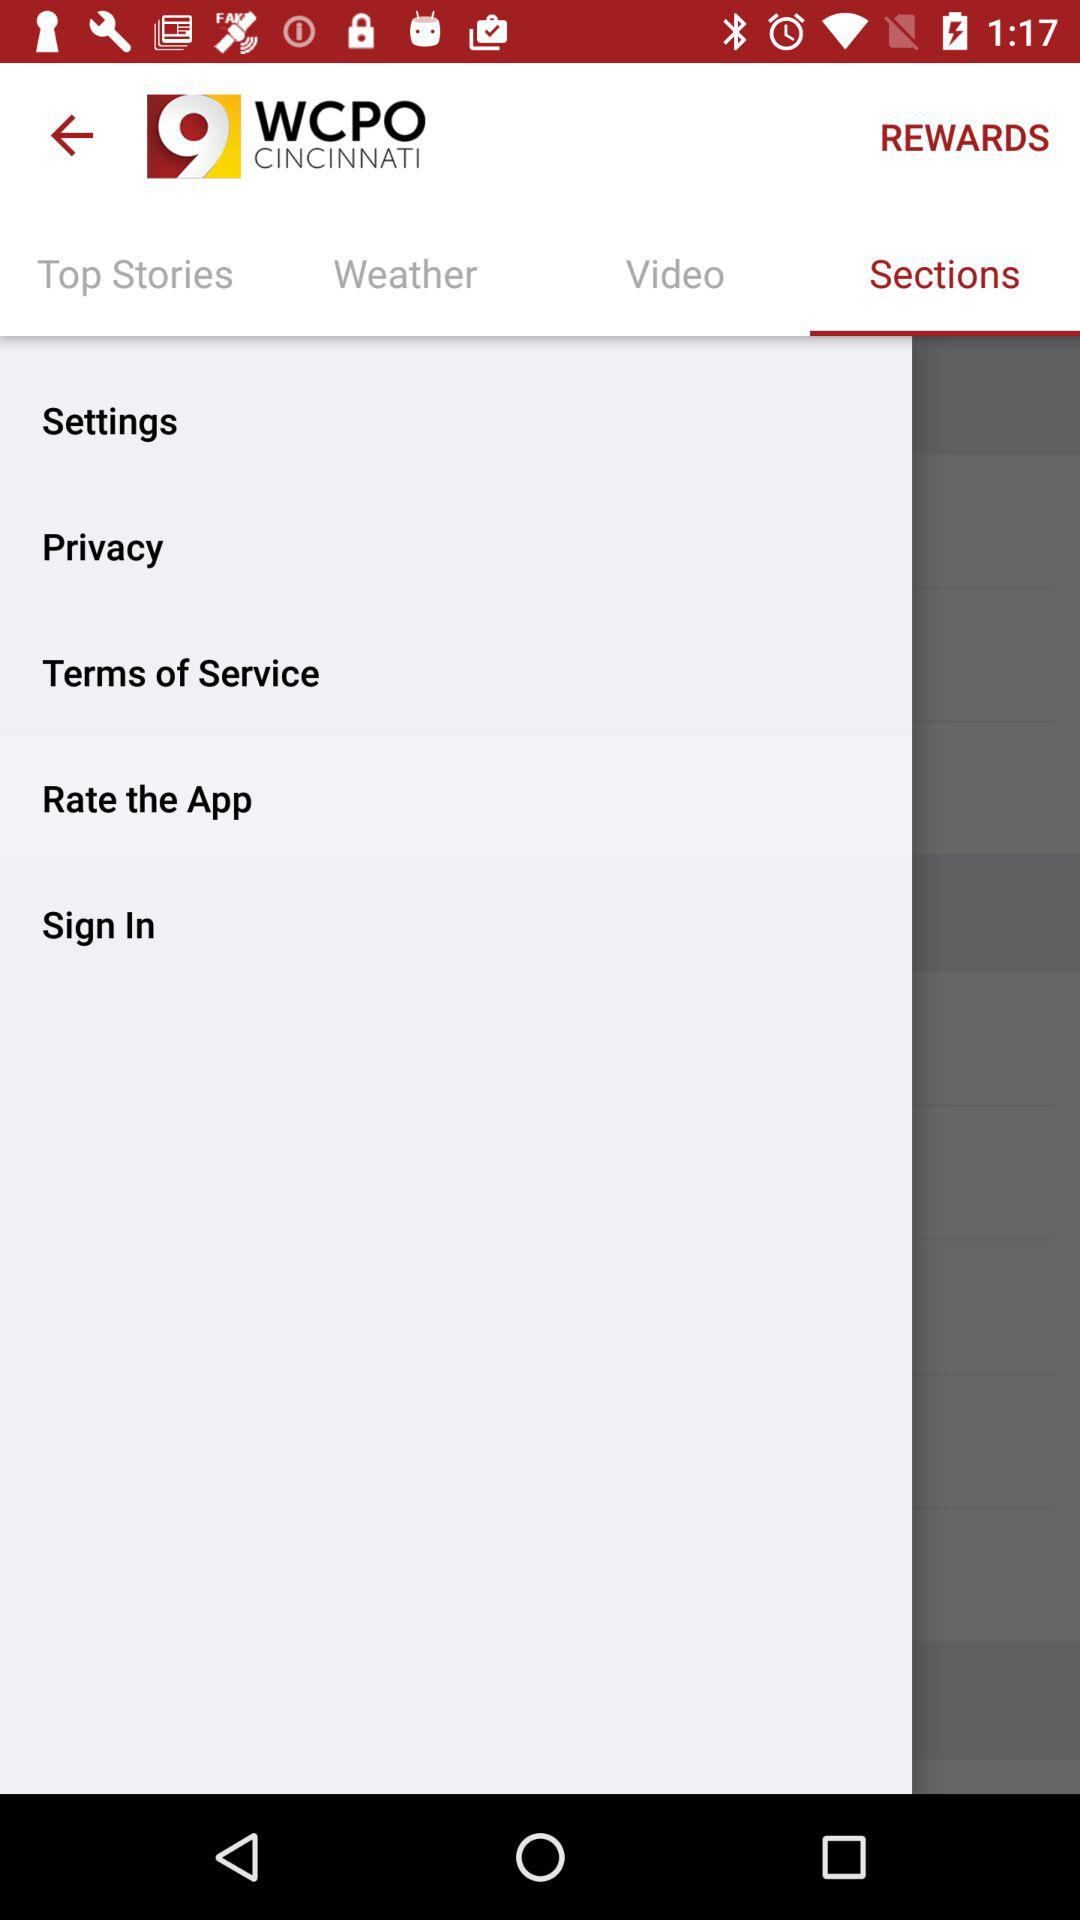What is the rating of the application?
When the provided information is insufficient, respond with <no answer>. <no answer> 